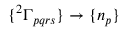<formula> <loc_0><loc_0><loc_500><loc_500>\{ { ^ { 2 } \Gamma _ { p q r s } } \} \to \{ n _ { p } \}</formula> 